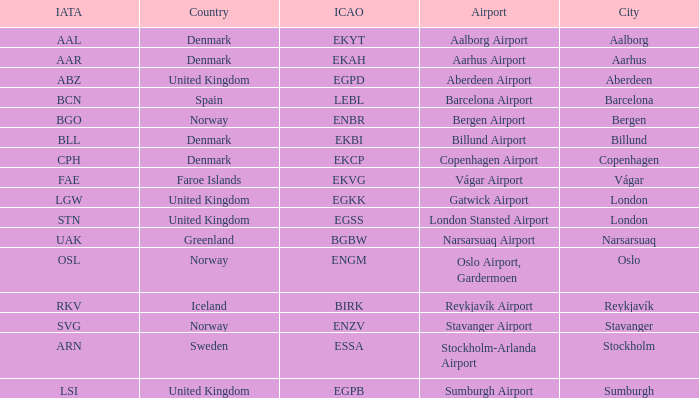What airport has an ICAP of BGBW? Narsarsuaq Airport. Would you mind parsing the complete table? {'header': ['IATA', 'Country', 'ICAO', 'Airport', 'City'], 'rows': [['AAL', 'Denmark', 'EKYT', 'Aalborg Airport', 'Aalborg'], ['AAR', 'Denmark', 'EKAH', 'Aarhus Airport', 'Aarhus'], ['ABZ', 'United Kingdom', 'EGPD', 'Aberdeen Airport', 'Aberdeen'], ['BCN', 'Spain', 'LEBL', 'Barcelona Airport', 'Barcelona'], ['BGO', 'Norway', 'ENBR', 'Bergen Airport', 'Bergen'], ['BLL', 'Denmark', 'EKBI', 'Billund Airport', 'Billund'], ['CPH', 'Denmark', 'EKCP', 'Copenhagen Airport', 'Copenhagen'], ['FAE', 'Faroe Islands', 'EKVG', 'Vágar Airport', 'Vágar'], ['LGW', 'United Kingdom', 'EGKK', 'Gatwick Airport', 'London'], ['STN', 'United Kingdom', 'EGSS', 'London Stansted Airport', 'London'], ['UAK', 'Greenland', 'BGBW', 'Narsarsuaq Airport', 'Narsarsuaq'], ['OSL', 'Norway', 'ENGM', 'Oslo Airport, Gardermoen', 'Oslo'], ['RKV', 'Iceland', 'BIRK', 'Reykjavík Airport', 'Reykjavík'], ['SVG', 'Norway', 'ENZV', 'Stavanger Airport', 'Stavanger'], ['ARN', 'Sweden', 'ESSA', 'Stockholm-Arlanda Airport', 'Stockholm'], ['LSI', 'United Kingdom', 'EGPB', 'Sumburgh Airport', 'Sumburgh']]} 